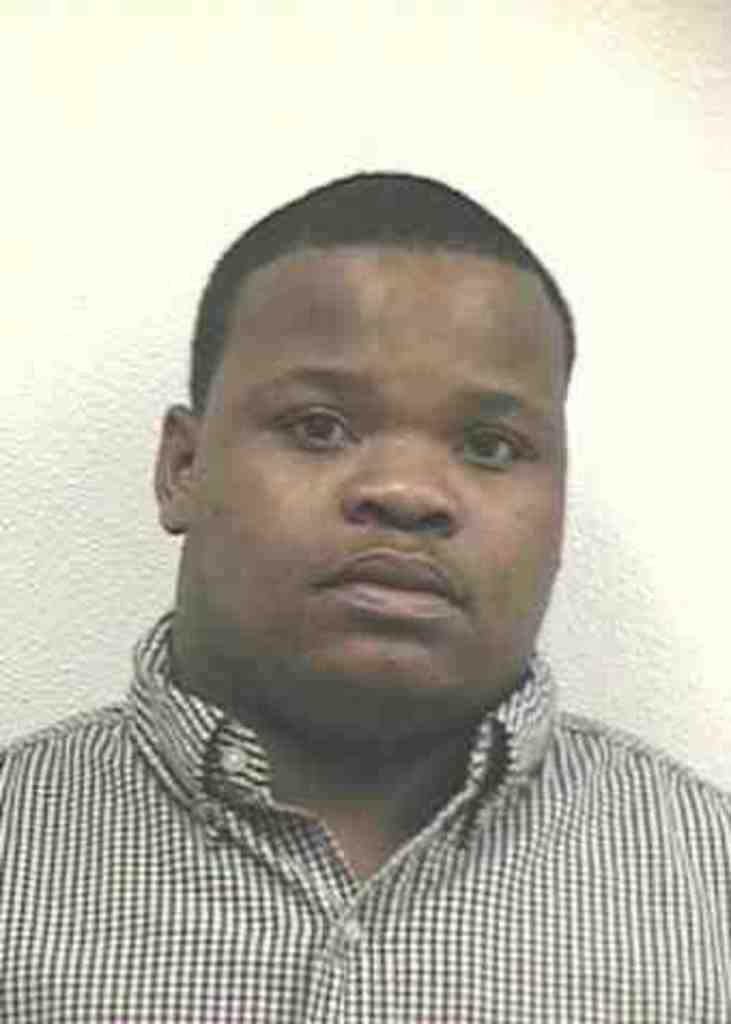What is the main subject of the image? There is a person in the image. Can you describe the person's hair color? The person has black hair. What can be seen behind the person in the image? There is a colored background in the image. How many bubbles can be seen around the person in the image? There are no bubbles present in the image. What type of clothing are the girls wearing in the image? There are no girls present in the image, only one person. 